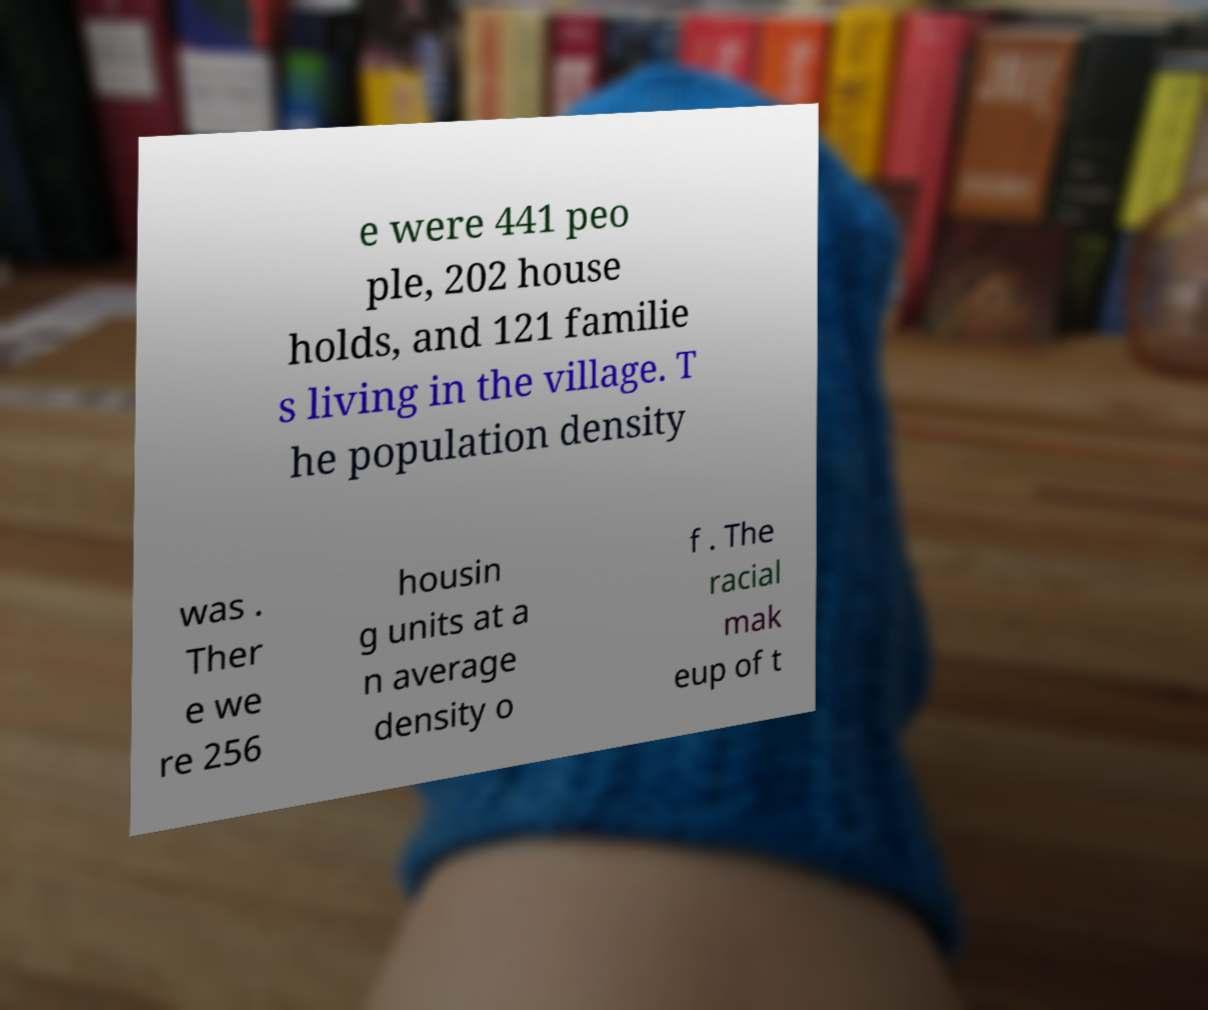Can you accurately transcribe the text from the provided image for me? e were 441 peo ple, 202 house holds, and 121 familie s living in the village. T he population density was . Ther e we re 256 housin g units at a n average density o f . The racial mak eup of t 